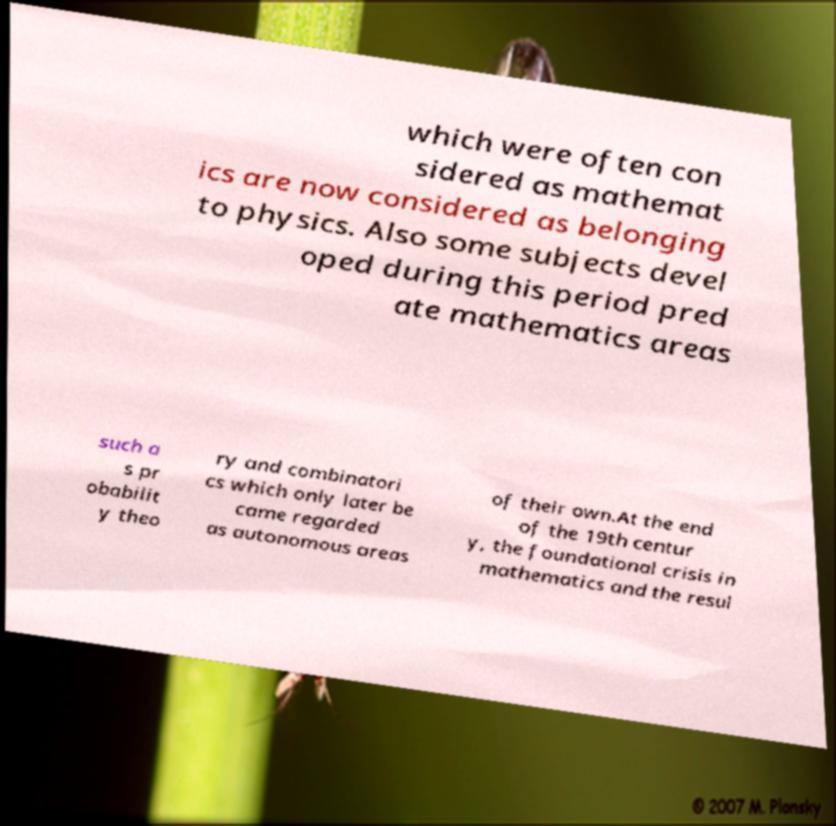Please identify and transcribe the text found in this image. which were often con sidered as mathemat ics are now considered as belonging to physics. Also some subjects devel oped during this period pred ate mathematics areas such a s pr obabilit y theo ry and combinatori cs which only later be came regarded as autonomous areas of their own.At the end of the 19th centur y, the foundational crisis in mathematics and the resul 